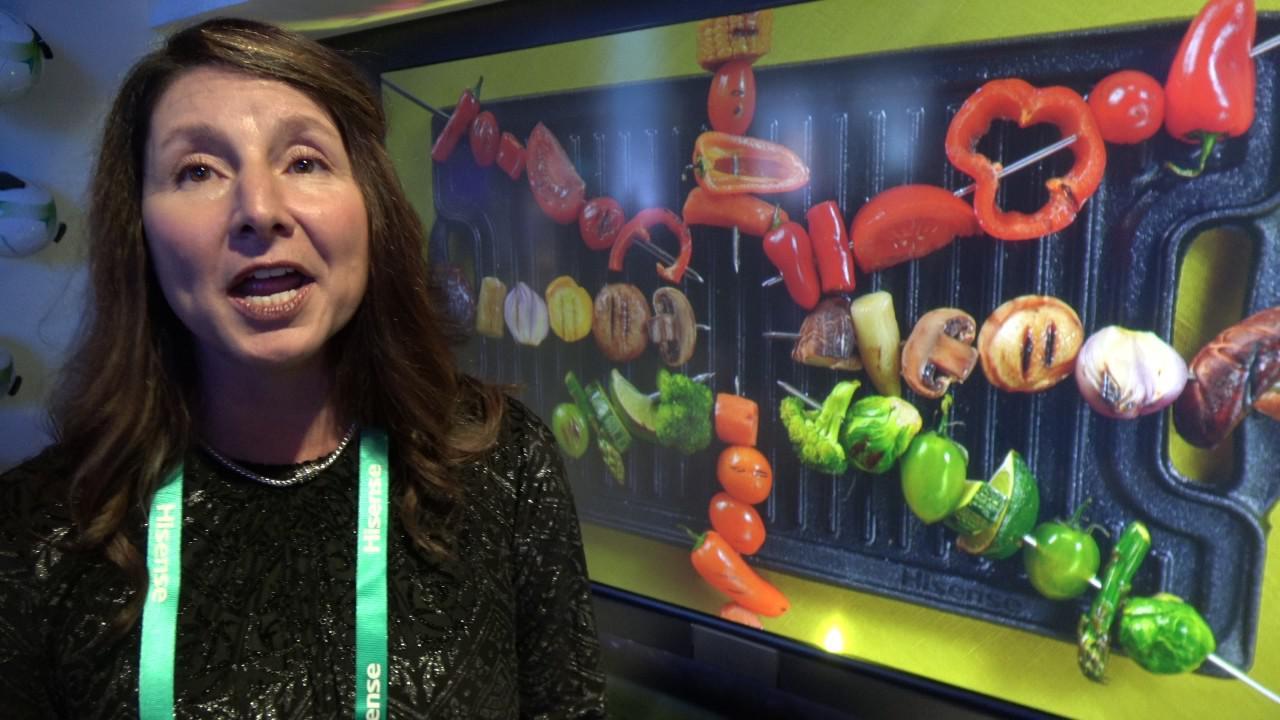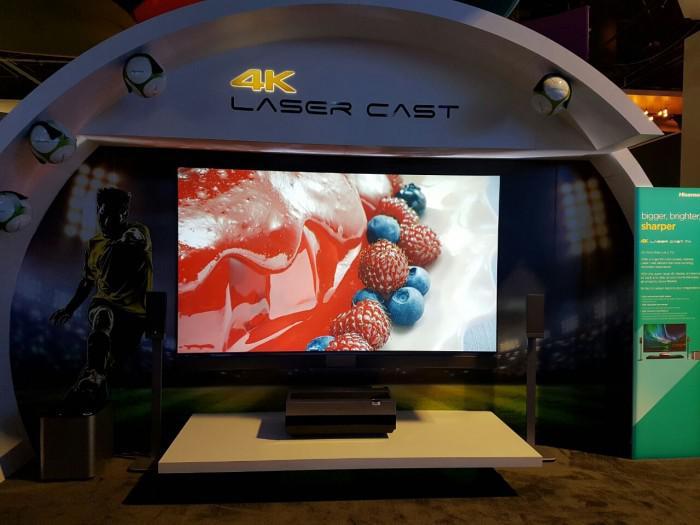The first image is the image on the left, the second image is the image on the right. Examine the images to the left and right. Is the description "One image shows an arch over a screen displaying a picture of red and blue berries around a shiny red rounded thing." accurate? Answer yes or no. Yes. The first image is the image on the left, the second image is the image on the right. Considering the images on both sides, is "The image in the right television display portrays a person." valid? Answer yes or no. No. 